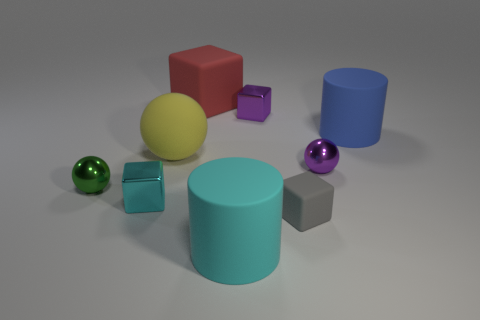There is a small purple object behind the blue matte cylinder; does it have the same shape as the small cyan thing?
Your response must be concise. Yes. Are there fewer tiny shiny spheres than yellow rubber balls?
Your answer should be very brief. No. What material is the cyan thing that is the same size as the green thing?
Keep it short and to the point. Metal. Is the number of purple metal balls to the left of the cyan metallic cube less than the number of small gray cylinders?
Offer a very short reply. No. How many small yellow rubber objects are there?
Offer a terse response. 0. What shape is the cyan object in front of the cyan object behind the tiny rubber object?
Your answer should be compact. Cylinder. There is a gray matte object; how many small purple cubes are left of it?
Your response must be concise. 1. Does the large blue thing have the same material as the big cylinder that is left of the big blue rubber thing?
Provide a succinct answer. Yes. Is there a red block of the same size as the yellow rubber object?
Offer a very short reply. Yes. Is the number of green metal things that are behind the blue rubber object the same as the number of tiny cyan blocks?
Your answer should be compact. No. 